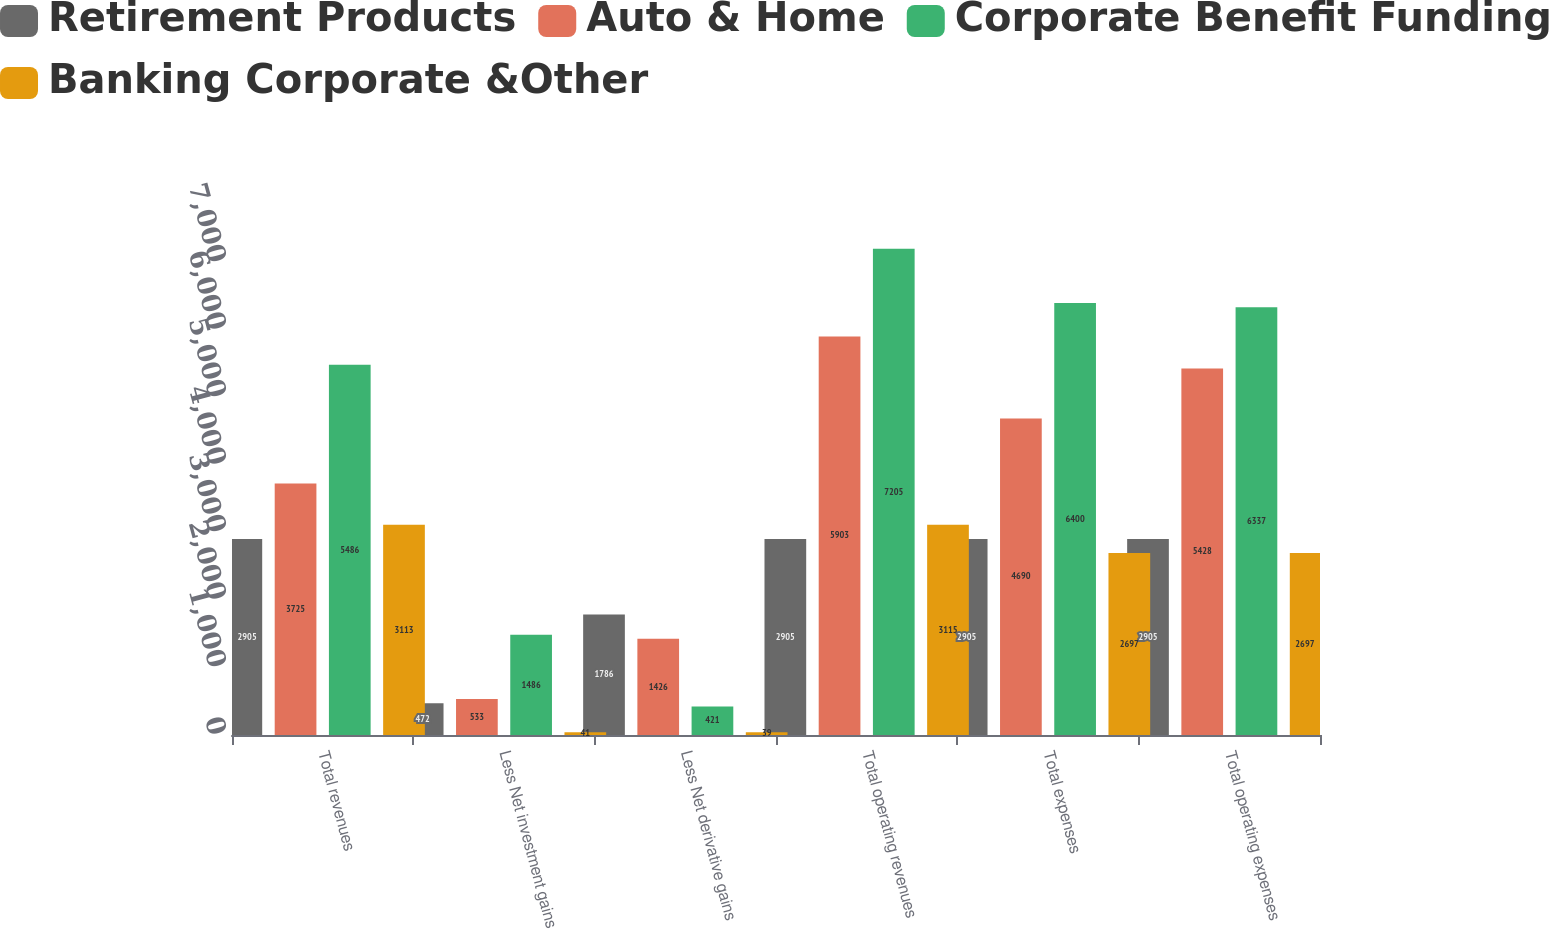Convert chart to OTSL. <chart><loc_0><loc_0><loc_500><loc_500><stacked_bar_chart><ecel><fcel>Total revenues<fcel>Less Net investment gains<fcel>Less Net derivative gains<fcel>Total operating revenues<fcel>Total expenses<fcel>Total operating expenses<nl><fcel>Retirement Products<fcel>2905<fcel>472<fcel>1786<fcel>2905<fcel>2905<fcel>2905<nl><fcel>Auto & Home<fcel>3725<fcel>533<fcel>1426<fcel>5903<fcel>4690<fcel>5428<nl><fcel>Corporate Benefit Funding<fcel>5486<fcel>1486<fcel>421<fcel>7205<fcel>6400<fcel>6337<nl><fcel>Banking Corporate &Other<fcel>3113<fcel>41<fcel>39<fcel>3115<fcel>2697<fcel>2697<nl></chart> 